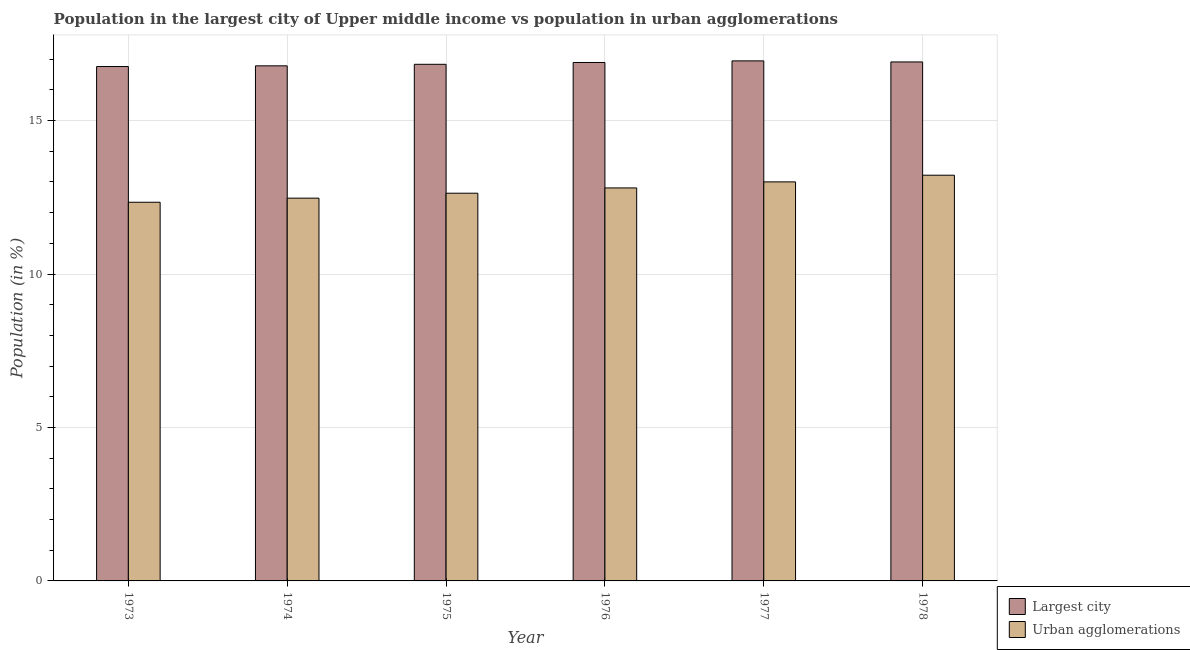How many groups of bars are there?
Provide a short and direct response. 6. Are the number of bars per tick equal to the number of legend labels?
Ensure brevity in your answer.  Yes. Are the number of bars on each tick of the X-axis equal?
Make the answer very short. Yes. How many bars are there on the 5th tick from the right?
Keep it short and to the point. 2. What is the label of the 1st group of bars from the left?
Your answer should be very brief. 1973. What is the population in the largest city in 1973?
Your answer should be compact. 16.76. Across all years, what is the maximum population in urban agglomerations?
Your response must be concise. 13.22. Across all years, what is the minimum population in urban agglomerations?
Provide a succinct answer. 12.34. In which year was the population in urban agglomerations maximum?
Your answer should be very brief. 1978. In which year was the population in urban agglomerations minimum?
Offer a terse response. 1973. What is the total population in urban agglomerations in the graph?
Your response must be concise. 76.48. What is the difference between the population in the largest city in 1976 and that in 1978?
Keep it short and to the point. -0.02. What is the difference between the population in urban agglomerations in 1975 and the population in the largest city in 1973?
Provide a short and direct response. 0.29. What is the average population in urban agglomerations per year?
Provide a short and direct response. 12.75. In how many years, is the population in urban agglomerations greater than 12 %?
Offer a terse response. 6. What is the ratio of the population in the largest city in 1973 to that in 1977?
Your response must be concise. 0.99. Is the population in the largest city in 1974 less than that in 1975?
Make the answer very short. Yes. Is the difference between the population in the largest city in 1975 and 1976 greater than the difference between the population in urban agglomerations in 1975 and 1976?
Your answer should be compact. No. What is the difference between the highest and the second highest population in urban agglomerations?
Your answer should be very brief. 0.22. What is the difference between the highest and the lowest population in the largest city?
Offer a terse response. 0.18. Is the sum of the population in the largest city in 1974 and 1975 greater than the maximum population in urban agglomerations across all years?
Your answer should be compact. Yes. What does the 2nd bar from the left in 1978 represents?
Offer a terse response. Urban agglomerations. What does the 2nd bar from the right in 1974 represents?
Keep it short and to the point. Largest city. How many bars are there?
Offer a very short reply. 12. Are all the bars in the graph horizontal?
Provide a succinct answer. No. How many years are there in the graph?
Your answer should be very brief. 6. What is the difference between two consecutive major ticks on the Y-axis?
Offer a terse response. 5. Where does the legend appear in the graph?
Your answer should be very brief. Bottom right. How many legend labels are there?
Provide a short and direct response. 2. What is the title of the graph?
Keep it short and to the point. Population in the largest city of Upper middle income vs population in urban agglomerations. What is the label or title of the X-axis?
Offer a terse response. Year. What is the Population (in %) in Largest city in 1973?
Provide a short and direct response. 16.76. What is the Population (in %) in Urban agglomerations in 1973?
Provide a succinct answer. 12.34. What is the Population (in %) of Largest city in 1974?
Offer a very short reply. 16.79. What is the Population (in %) of Urban agglomerations in 1974?
Offer a terse response. 12.47. What is the Population (in %) in Largest city in 1975?
Offer a terse response. 16.83. What is the Population (in %) in Urban agglomerations in 1975?
Offer a very short reply. 12.63. What is the Population (in %) in Largest city in 1976?
Your answer should be very brief. 16.89. What is the Population (in %) of Urban agglomerations in 1976?
Provide a short and direct response. 12.81. What is the Population (in %) of Largest city in 1977?
Offer a very short reply. 16.95. What is the Population (in %) in Urban agglomerations in 1977?
Ensure brevity in your answer.  13. What is the Population (in %) of Largest city in 1978?
Provide a short and direct response. 16.91. What is the Population (in %) in Urban agglomerations in 1978?
Your response must be concise. 13.22. Across all years, what is the maximum Population (in %) in Largest city?
Make the answer very short. 16.95. Across all years, what is the maximum Population (in %) of Urban agglomerations?
Offer a terse response. 13.22. Across all years, what is the minimum Population (in %) in Largest city?
Offer a very short reply. 16.76. Across all years, what is the minimum Population (in %) of Urban agglomerations?
Make the answer very short. 12.34. What is the total Population (in %) of Largest city in the graph?
Your response must be concise. 101.13. What is the total Population (in %) of Urban agglomerations in the graph?
Your answer should be very brief. 76.48. What is the difference between the Population (in %) of Largest city in 1973 and that in 1974?
Give a very brief answer. -0.02. What is the difference between the Population (in %) of Urban agglomerations in 1973 and that in 1974?
Your answer should be very brief. -0.13. What is the difference between the Population (in %) of Largest city in 1973 and that in 1975?
Offer a terse response. -0.07. What is the difference between the Population (in %) in Urban agglomerations in 1973 and that in 1975?
Your answer should be very brief. -0.29. What is the difference between the Population (in %) in Largest city in 1973 and that in 1976?
Provide a succinct answer. -0.13. What is the difference between the Population (in %) in Urban agglomerations in 1973 and that in 1976?
Your answer should be compact. -0.47. What is the difference between the Population (in %) in Largest city in 1973 and that in 1977?
Provide a short and direct response. -0.18. What is the difference between the Population (in %) of Urban agglomerations in 1973 and that in 1977?
Your answer should be compact. -0.66. What is the difference between the Population (in %) of Largest city in 1973 and that in 1978?
Provide a succinct answer. -0.15. What is the difference between the Population (in %) of Urban agglomerations in 1973 and that in 1978?
Your response must be concise. -0.88. What is the difference between the Population (in %) in Largest city in 1974 and that in 1975?
Provide a succinct answer. -0.05. What is the difference between the Population (in %) of Urban agglomerations in 1974 and that in 1975?
Your answer should be compact. -0.16. What is the difference between the Population (in %) of Largest city in 1974 and that in 1976?
Keep it short and to the point. -0.11. What is the difference between the Population (in %) of Urban agglomerations in 1974 and that in 1976?
Make the answer very short. -0.33. What is the difference between the Population (in %) in Largest city in 1974 and that in 1977?
Ensure brevity in your answer.  -0.16. What is the difference between the Population (in %) of Urban agglomerations in 1974 and that in 1977?
Give a very brief answer. -0.53. What is the difference between the Population (in %) of Largest city in 1974 and that in 1978?
Your answer should be very brief. -0.13. What is the difference between the Population (in %) in Urban agglomerations in 1974 and that in 1978?
Your response must be concise. -0.75. What is the difference between the Population (in %) of Largest city in 1975 and that in 1976?
Your response must be concise. -0.06. What is the difference between the Population (in %) of Urban agglomerations in 1975 and that in 1976?
Make the answer very short. -0.17. What is the difference between the Population (in %) of Largest city in 1975 and that in 1977?
Make the answer very short. -0.11. What is the difference between the Population (in %) in Urban agglomerations in 1975 and that in 1977?
Offer a very short reply. -0.37. What is the difference between the Population (in %) of Largest city in 1975 and that in 1978?
Your response must be concise. -0.08. What is the difference between the Population (in %) of Urban agglomerations in 1975 and that in 1978?
Provide a short and direct response. -0.59. What is the difference between the Population (in %) of Largest city in 1976 and that in 1977?
Your response must be concise. -0.05. What is the difference between the Population (in %) of Urban agglomerations in 1976 and that in 1977?
Make the answer very short. -0.2. What is the difference between the Population (in %) in Largest city in 1976 and that in 1978?
Keep it short and to the point. -0.02. What is the difference between the Population (in %) in Urban agglomerations in 1976 and that in 1978?
Make the answer very short. -0.41. What is the difference between the Population (in %) in Largest city in 1977 and that in 1978?
Your response must be concise. 0.03. What is the difference between the Population (in %) in Urban agglomerations in 1977 and that in 1978?
Give a very brief answer. -0.22. What is the difference between the Population (in %) of Largest city in 1973 and the Population (in %) of Urban agglomerations in 1974?
Keep it short and to the point. 4.29. What is the difference between the Population (in %) in Largest city in 1973 and the Population (in %) in Urban agglomerations in 1975?
Your response must be concise. 4.13. What is the difference between the Population (in %) of Largest city in 1973 and the Population (in %) of Urban agglomerations in 1976?
Offer a very short reply. 3.96. What is the difference between the Population (in %) of Largest city in 1973 and the Population (in %) of Urban agglomerations in 1977?
Your response must be concise. 3.76. What is the difference between the Population (in %) in Largest city in 1973 and the Population (in %) in Urban agglomerations in 1978?
Your answer should be compact. 3.54. What is the difference between the Population (in %) in Largest city in 1974 and the Population (in %) in Urban agglomerations in 1975?
Your answer should be compact. 4.15. What is the difference between the Population (in %) of Largest city in 1974 and the Population (in %) of Urban agglomerations in 1976?
Your answer should be compact. 3.98. What is the difference between the Population (in %) in Largest city in 1974 and the Population (in %) in Urban agglomerations in 1977?
Your answer should be compact. 3.78. What is the difference between the Population (in %) in Largest city in 1974 and the Population (in %) in Urban agglomerations in 1978?
Make the answer very short. 3.56. What is the difference between the Population (in %) of Largest city in 1975 and the Population (in %) of Urban agglomerations in 1976?
Offer a very short reply. 4.03. What is the difference between the Population (in %) in Largest city in 1975 and the Population (in %) in Urban agglomerations in 1977?
Make the answer very short. 3.83. What is the difference between the Population (in %) in Largest city in 1975 and the Population (in %) in Urban agglomerations in 1978?
Offer a terse response. 3.61. What is the difference between the Population (in %) in Largest city in 1976 and the Population (in %) in Urban agglomerations in 1977?
Offer a terse response. 3.89. What is the difference between the Population (in %) in Largest city in 1976 and the Population (in %) in Urban agglomerations in 1978?
Give a very brief answer. 3.67. What is the difference between the Population (in %) in Largest city in 1977 and the Population (in %) in Urban agglomerations in 1978?
Your answer should be very brief. 3.73. What is the average Population (in %) in Largest city per year?
Provide a short and direct response. 16.86. What is the average Population (in %) of Urban agglomerations per year?
Provide a short and direct response. 12.75. In the year 1973, what is the difference between the Population (in %) in Largest city and Population (in %) in Urban agglomerations?
Provide a succinct answer. 4.42. In the year 1974, what is the difference between the Population (in %) of Largest city and Population (in %) of Urban agglomerations?
Your response must be concise. 4.31. In the year 1975, what is the difference between the Population (in %) of Largest city and Population (in %) of Urban agglomerations?
Provide a short and direct response. 4.2. In the year 1976, what is the difference between the Population (in %) in Largest city and Population (in %) in Urban agglomerations?
Offer a terse response. 4.09. In the year 1977, what is the difference between the Population (in %) in Largest city and Population (in %) in Urban agglomerations?
Your answer should be very brief. 3.94. In the year 1978, what is the difference between the Population (in %) in Largest city and Population (in %) in Urban agglomerations?
Provide a short and direct response. 3.69. What is the ratio of the Population (in %) of Urban agglomerations in 1973 to that in 1974?
Provide a short and direct response. 0.99. What is the ratio of the Population (in %) of Largest city in 1973 to that in 1975?
Offer a terse response. 1. What is the ratio of the Population (in %) of Urban agglomerations in 1973 to that in 1975?
Provide a short and direct response. 0.98. What is the ratio of the Population (in %) of Urban agglomerations in 1973 to that in 1976?
Make the answer very short. 0.96. What is the ratio of the Population (in %) of Urban agglomerations in 1973 to that in 1977?
Your answer should be very brief. 0.95. What is the ratio of the Population (in %) of Largest city in 1973 to that in 1978?
Provide a succinct answer. 0.99. What is the ratio of the Population (in %) of Urban agglomerations in 1973 to that in 1978?
Make the answer very short. 0.93. What is the ratio of the Population (in %) in Largest city in 1974 to that in 1975?
Give a very brief answer. 1. What is the ratio of the Population (in %) in Urban agglomerations in 1974 to that in 1975?
Your answer should be compact. 0.99. What is the ratio of the Population (in %) in Urban agglomerations in 1974 to that in 1976?
Give a very brief answer. 0.97. What is the ratio of the Population (in %) of Urban agglomerations in 1974 to that in 1977?
Your answer should be compact. 0.96. What is the ratio of the Population (in %) of Urban agglomerations in 1974 to that in 1978?
Make the answer very short. 0.94. What is the ratio of the Population (in %) of Largest city in 1975 to that in 1976?
Keep it short and to the point. 1. What is the ratio of the Population (in %) in Urban agglomerations in 1975 to that in 1976?
Give a very brief answer. 0.99. What is the ratio of the Population (in %) of Largest city in 1975 to that in 1977?
Your answer should be very brief. 0.99. What is the ratio of the Population (in %) of Urban agglomerations in 1975 to that in 1977?
Provide a succinct answer. 0.97. What is the ratio of the Population (in %) of Largest city in 1975 to that in 1978?
Make the answer very short. 1. What is the ratio of the Population (in %) in Urban agglomerations in 1975 to that in 1978?
Your response must be concise. 0.96. What is the ratio of the Population (in %) of Urban agglomerations in 1976 to that in 1977?
Offer a terse response. 0.98. What is the ratio of the Population (in %) in Largest city in 1976 to that in 1978?
Ensure brevity in your answer.  1. What is the ratio of the Population (in %) in Urban agglomerations in 1976 to that in 1978?
Provide a short and direct response. 0.97. What is the ratio of the Population (in %) of Largest city in 1977 to that in 1978?
Your answer should be very brief. 1. What is the ratio of the Population (in %) in Urban agglomerations in 1977 to that in 1978?
Give a very brief answer. 0.98. What is the difference between the highest and the second highest Population (in %) in Largest city?
Make the answer very short. 0.03. What is the difference between the highest and the second highest Population (in %) of Urban agglomerations?
Provide a short and direct response. 0.22. What is the difference between the highest and the lowest Population (in %) in Largest city?
Your response must be concise. 0.18. What is the difference between the highest and the lowest Population (in %) in Urban agglomerations?
Offer a terse response. 0.88. 